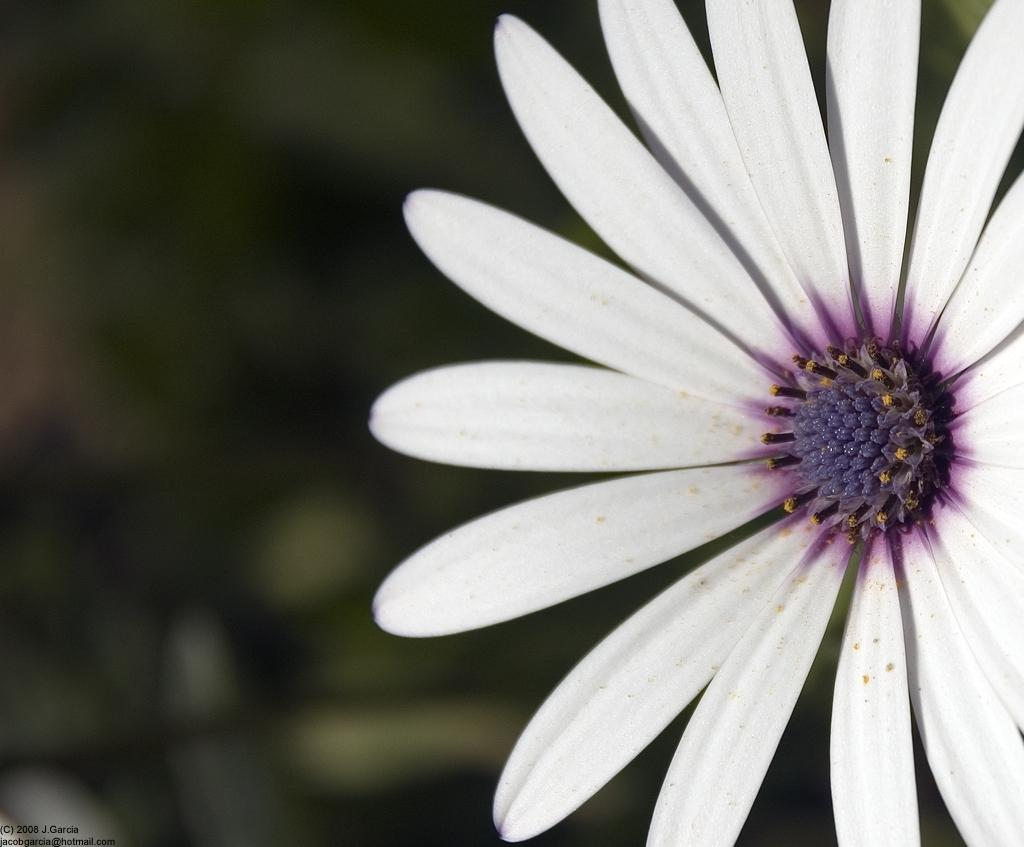What is the main subject of the image? There is a flower in the image. Can you describe the background of the image? The background of the image is blurred. How many ladybugs are sitting on the silk fabric in the image? There is no silk fabric or ladybugs present in the image; it features a flower with a blurred background. 